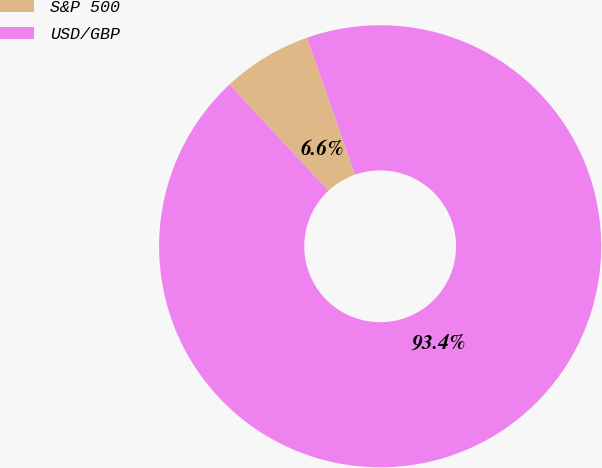<chart> <loc_0><loc_0><loc_500><loc_500><pie_chart><fcel>S&P 500<fcel>USD/GBP<nl><fcel>6.56%<fcel>93.44%<nl></chart> 